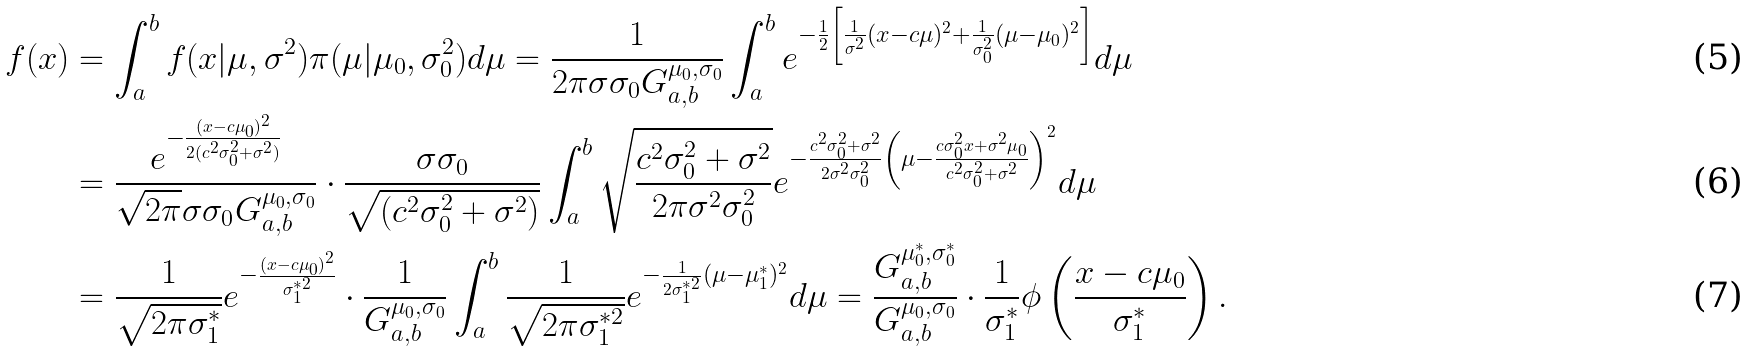<formula> <loc_0><loc_0><loc_500><loc_500>f ( x ) & = \int _ { a } ^ { b } f ( x | \mu , \sigma ^ { 2 } ) \pi ( \mu | \mu _ { 0 } , \sigma _ { 0 } ^ { 2 } ) d \mu = \frac { 1 } { 2 \pi \sigma \sigma _ { 0 } G _ { a , b } ^ { \mu _ { 0 } , \sigma _ { 0 } } } \int _ { a } ^ { b } e ^ { - \frac { 1 } { 2 } \left [ \frac { 1 } { \sigma ^ { 2 } } ( x - c \mu ) ^ { 2 } + \frac { 1 } { \sigma _ { 0 } ^ { 2 } } ( \mu - \mu _ { 0 } ) ^ { 2 } \right ] } d \mu \\ & = \frac { e ^ { - \frac { ( x - c \mu _ { 0 } ) ^ { 2 } } { 2 ( c ^ { 2 } \sigma _ { 0 } ^ { 2 } + \sigma ^ { 2 } ) } } } { \sqrt { 2 \pi } \sigma \sigma _ { 0 } G _ { a , b } ^ { \mu _ { 0 } , \sigma _ { 0 } } } \cdot \frac { \sigma \sigma _ { 0 } } { \sqrt { ( c ^ { 2 } \sigma _ { 0 } ^ { 2 } + \sigma ^ { 2 } ) } } \int _ { a } ^ { b } \sqrt { \frac { c ^ { 2 } \sigma _ { 0 } ^ { 2 } + \sigma ^ { 2 } } { 2 \pi \sigma ^ { 2 } \sigma _ { 0 } ^ { 2 } } } e ^ { - \frac { c ^ { 2 } \sigma _ { 0 } ^ { 2 } + \sigma ^ { 2 } } { 2 \sigma ^ { 2 } \sigma _ { 0 } ^ { 2 } } \left ( \mu - \frac { c \sigma _ { 0 } ^ { 2 } x + \sigma ^ { 2 } \mu _ { 0 } } { c ^ { 2 } \sigma _ { 0 } ^ { 2 } + \sigma ^ { 2 } } \right ) ^ { 2 } } d \mu \\ & = \frac { 1 } { \sqrt { 2 \pi \sigma _ { 1 } ^ { * } } } e ^ { - \frac { ( x - c \mu _ { 0 } ) ^ { 2 } } { \sigma _ { 1 } ^ { * 2 } } } \cdot \frac { 1 } { G _ { a , b } ^ { \mu _ { 0 } , \sigma _ { 0 } } } \int _ { a } ^ { b } \frac { 1 } { \sqrt { 2 \pi \sigma _ { 1 } ^ { * 2 } } } e ^ { - \frac { 1 } { 2 \sigma _ { 1 } ^ { * 2 } } ( \mu - \mu _ { 1 } ^ { * } ) ^ { 2 } } d \mu = \frac { G _ { a , b } ^ { \mu _ { 0 } ^ { * } , \sigma _ { 0 } ^ { * } } } { G _ { a , b } ^ { \mu _ { 0 } , \sigma _ { 0 } } } \cdot \frac { 1 } { \sigma _ { 1 } ^ { * } } \phi \left ( \frac { x - c \mu _ { 0 } } { \sigma _ { 1 } ^ { * } } \right ) .</formula> 